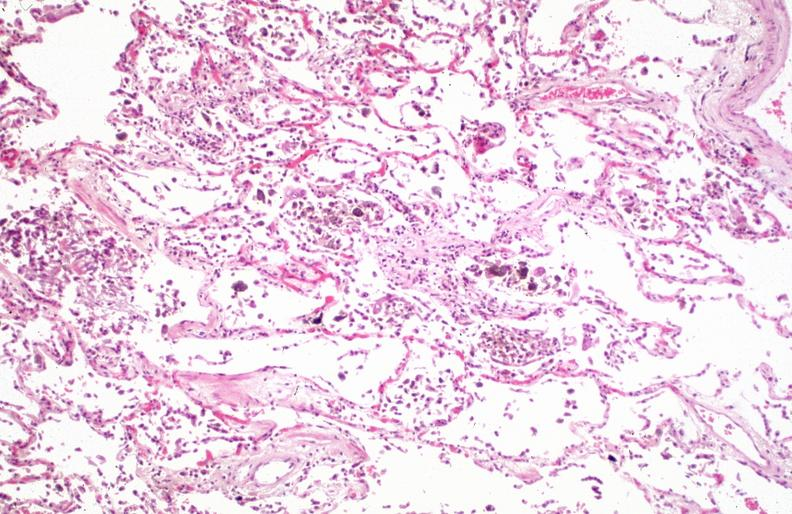how does this image show lung, pneumonia and hemosiderin laden macrophages in patient?
Answer the question using a single word or phrase. With sickle cell disease iatrogenic hemosiderosis 